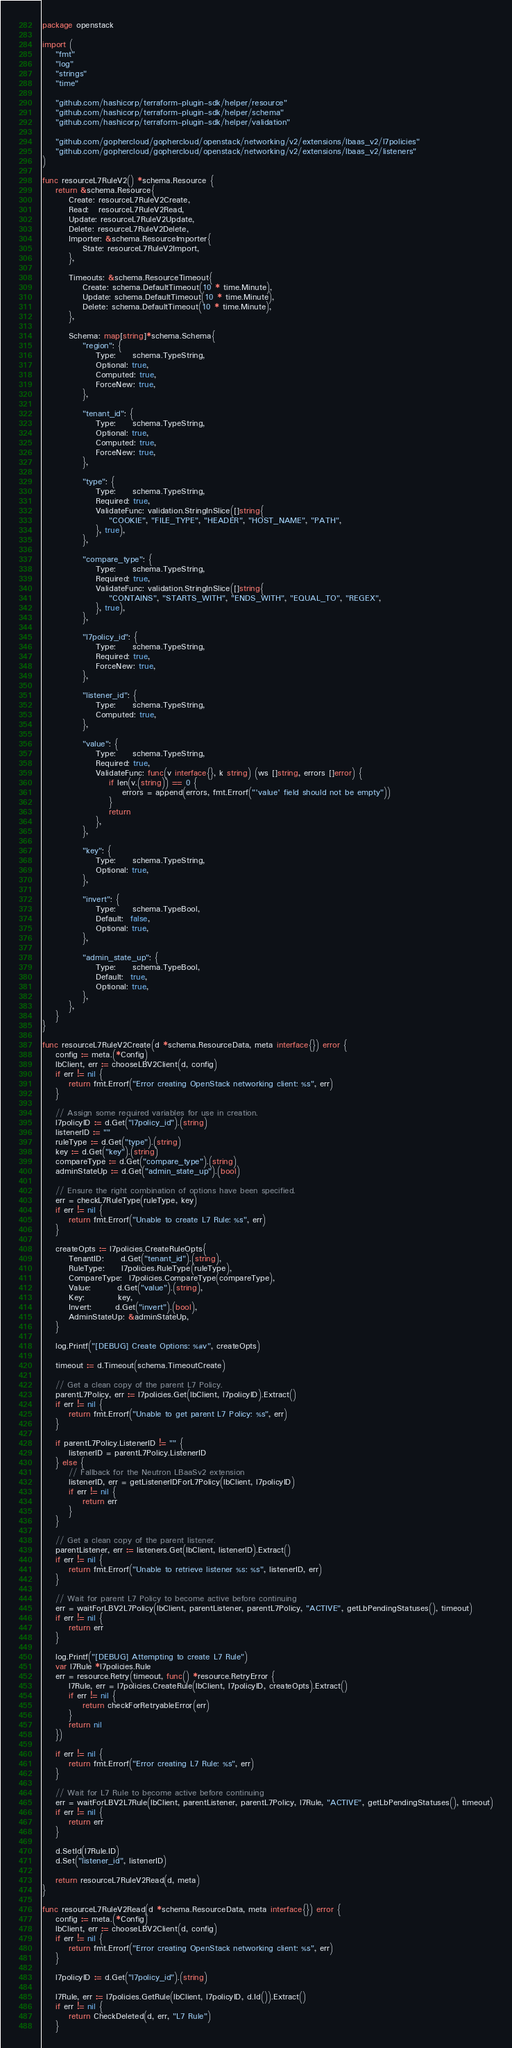Convert code to text. <code><loc_0><loc_0><loc_500><loc_500><_Go_>package openstack

import (
	"fmt"
	"log"
	"strings"
	"time"

	"github.com/hashicorp/terraform-plugin-sdk/helper/resource"
	"github.com/hashicorp/terraform-plugin-sdk/helper/schema"
	"github.com/hashicorp/terraform-plugin-sdk/helper/validation"

	"github.com/gophercloud/gophercloud/openstack/networking/v2/extensions/lbaas_v2/l7policies"
	"github.com/gophercloud/gophercloud/openstack/networking/v2/extensions/lbaas_v2/listeners"
)

func resourceL7RuleV2() *schema.Resource {
	return &schema.Resource{
		Create: resourceL7RuleV2Create,
		Read:   resourceL7RuleV2Read,
		Update: resourceL7RuleV2Update,
		Delete: resourceL7RuleV2Delete,
		Importer: &schema.ResourceImporter{
			State: resourceL7RuleV2Import,
		},

		Timeouts: &schema.ResourceTimeout{
			Create: schema.DefaultTimeout(10 * time.Minute),
			Update: schema.DefaultTimeout(10 * time.Minute),
			Delete: schema.DefaultTimeout(10 * time.Minute),
		},

		Schema: map[string]*schema.Schema{
			"region": {
				Type:     schema.TypeString,
				Optional: true,
				Computed: true,
				ForceNew: true,
			},

			"tenant_id": {
				Type:     schema.TypeString,
				Optional: true,
				Computed: true,
				ForceNew: true,
			},

			"type": {
				Type:     schema.TypeString,
				Required: true,
				ValidateFunc: validation.StringInSlice([]string{
					"COOKIE", "FILE_TYPE", "HEADER", "HOST_NAME", "PATH",
				}, true),
			},

			"compare_type": {
				Type:     schema.TypeString,
				Required: true,
				ValidateFunc: validation.StringInSlice([]string{
					"CONTAINS", "STARTS_WITH", "ENDS_WITH", "EQUAL_TO", "REGEX",
				}, true),
			},

			"l7policy_id": {
				Type:     schema.TypeString,
				Required: true,
				ForceNew: true,
			},

			"listener_id": {
				Type:     schema.TypeString,
				Computed: true,
			},

			"value": {
				Type:     schema.TypeString,
				Required: true,
				ValidateFunc: func(v interface{}, k string) (ws []string, errors []error) {
					if len(v.(string)) == 0 {
						errors = append(errors, fmt.Errorf("'value' field should not be empty"))
					}
					return
				},
			},

			"key": {
				Type:     schema.TypeString,
				Optional: true,
			},

			"invert": {
				Type:     schema.TypeBool,
				Default:  false,
				Optional: true,
			},

			"admin_state_up": {
				Type:     schema.TypeBool,
				Default:  true,
				Optional: true,
			},
		},
	}
}

func resourceL7RuleV2Create(d *schema.ResourceData, meta interface{}) error {
	config := meta.(*Config)
	lbClient, err := chooseLBV2Client(d, config)
	if err != nil {
		return fmt.Errorf("Error creating OpenStack networking client: %s", err)
	}

	// Assign some required variables for use in creation.
	l7policyID := d.Get("l7policy_id").(string)
	listenerID := ""
	ruleType := d.Get("type").(string)
	key := d.Get("key").(string)
	compareType := d.Get("compare_type").(string)
	adminStateUp := d.Get("admin_state_up").(bool)

	// Ensure the right combination of options have been specified.
	err = checkL7RuleType(ruleType, key)
	if err != nil {
		return fmt.Errorf("Unable to create L7 Rule: %s", err)
	}

	createOpts := l7policies.CreateRuleOpts{
		TenantID:     d.Get("tenant_id").(string),
		RuleType:     l7policies.RuleType(ruleType),
		CompareType:  l7policies.CompareType(compareType),
		Value:        d.Get("value").(string),
		Key:          key,
		Invert:       d.Get("invert").(bool),
		AdminStateUp: &adminStateUp,
	}

	log.Printf("[DEBUG] Create Options: %#v", createOpts)

	timeout := d.Timeout(schema.TimeoutCreate)

	// Get a clean copy of the parent L7 Policy.
	parentL7Policy, err := l7policies.Get(lbClient, l7policyID).Extract()
	if err != nil {
		return fmt.Errorf("Unable to get parent L7 Policy: %s", err)
	}

	if parentL7Policy.ListenerID != "" {
		listenerID = parentL7Policy.ListenerID
	} else {
		// Fallback for the Neutron LBaaSv2 extension
		listenerID, err = getListenerIDForL7Policy(lbClient, l7policyID)
		if err != nil {
			return err
		}
	}

	// Get a clean copy of the parent listener.
	parentListener, err := listeners.Get(lbClient, listenerID).Extract()
	if err != nil {
		return fmt.Errorf("Unable to retrieve listener %s: %s", listenerID, err)
	}

	// Wait for parent L7 Policy to become active before continuing
	err = waitForLBV2L7Policy(lbClient, parentListener, parentL7Policy, "ACTIVE", getLbPendingStatuses(), timeout)
	if err != nil {
		return err
	}

	log.Printf("[DEBUG] Attempting to create L7 Rule")
	var l7Rule *l7policies.Rule
	err = resource.Retry(timeout, func() *resource.RetryError {
		l7Rule, err = l7policies.CreateRule(lbClient, l7policyID, createOpts).Extract()
		if err != nil {
			return checkForRetryableError(err)
		}
		return nil
	})

	if err != nil {
		return fmt.Errorf("Error creating L7 Rule: %s", err)
	}

	// Wait for L7 Rule to become active before continuing
	err = waitForLBV2L7Rule(lbClient, parentListener, parentL7Policy, l7Rule, "ACTIVE", getLbPendingStatuses(), timeout)
	if err != nil {
		return err
	}

	d.SetId(l7Rule.ID)
	d.Set("listener_id", listenerID)

	return resourceL7RuleV2Read(d, meta)
}

func resourceL7RuleV2Read(d *schema.ResourceData, meta interface{}) error {
	config := meta.(*Config)
	lbClient, err := chooseLBV2Client(d, config)
	if err != nil {
		return fmt.Errorf("Error creating OpenStack networking client: %s", err)
	}

	l7policyID := d.Get("l7policy_id").(string)

	l7Rule, err := l7policies.GetRule(lbClient, l7policyID, d.Id()).Extract()
	if err != nil {
		return CheckDeleted(d, err, "L7 Rule")
	}
</code> 